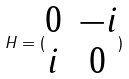Convert formula to latex. <formula><loc_0><loc_0><loc_500><loc_500>H = ( \begin{matrix} 0 & - i \\ i & 0 \end{matrix} )</formula> 